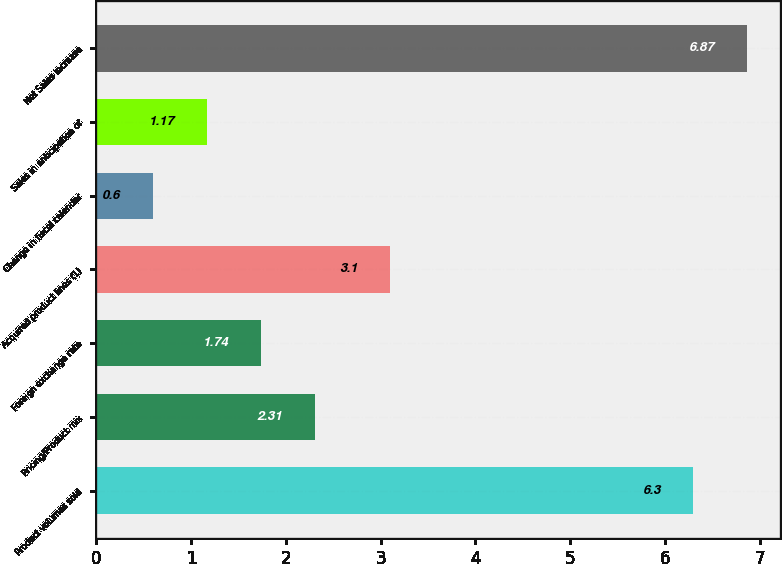<chart> <loc_0><loc_0><loc_500><loc_500><bar_chart><fcel>Product volumes sold<fcel>Pricing/Product mix<fcel>Foreign exchange rate<fcel>Acquired product lines (1)<fcel>Change in fiscal calendar<fcel>Sales in anticipation of<fcel>Net Sales increase<nl><fcel>6.3<fcel>2.31<fcel>1.74<fcel>3.1<fcel>0.6<fcel>1.17<fcel>6.87<nl></chart> 